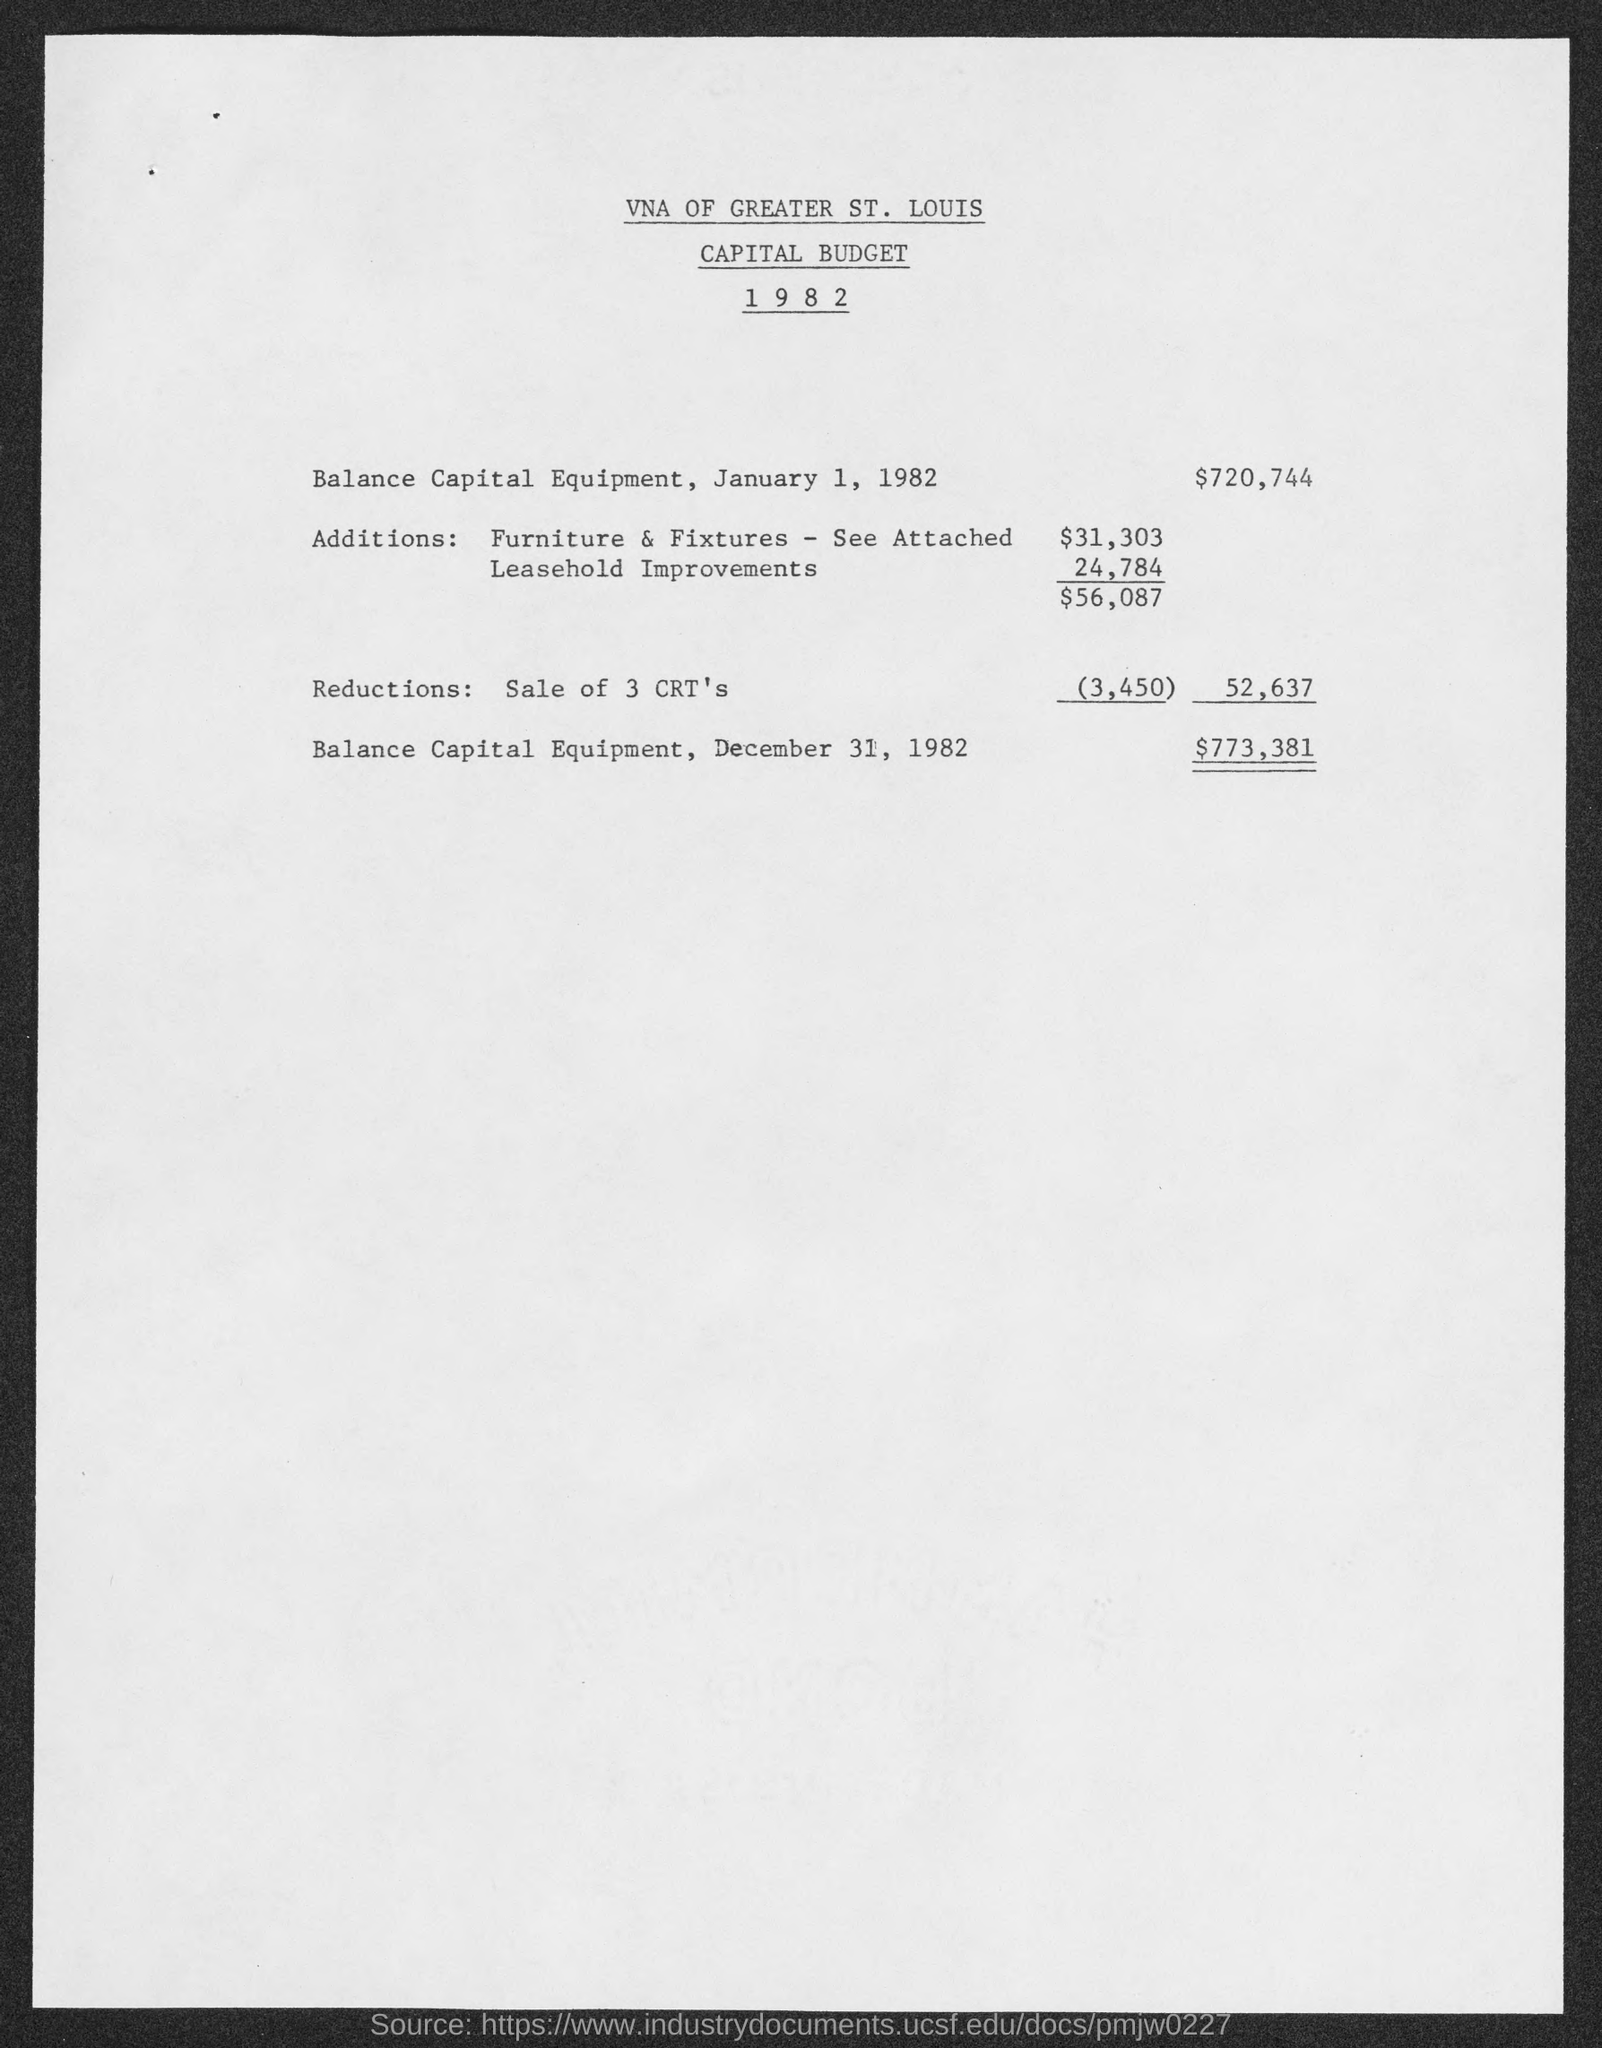Indicate a few pertinent items in this graphic. On December 31, 1982, the balance of capital equipment was $773,381. The capital budget of the company whose name is given here is VNA of Greater St. Louis. On January 1, 1982, the balance of capital equipment was $720,744. 